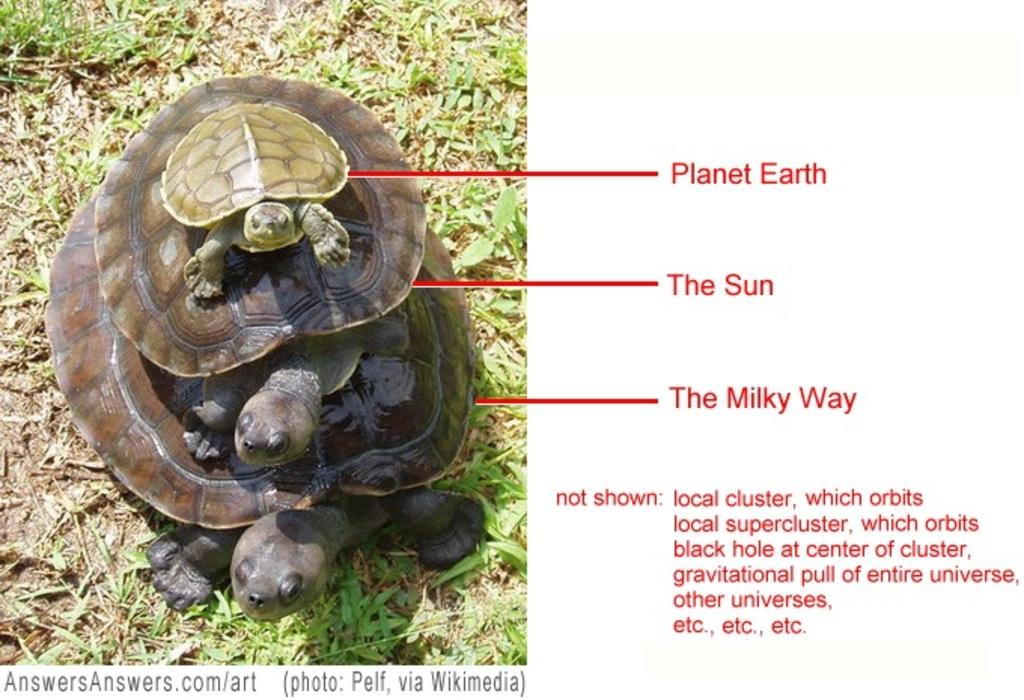How many turtles are present in the image? There are three turtles in the image. What is the turtles' location in the image? The turtles are standing on the grass. When was the image taken? The image was taken during the day. What type of wound can be seen on the man's arm in the image? There is no man present in the image, and therefore no wound can be observed. 